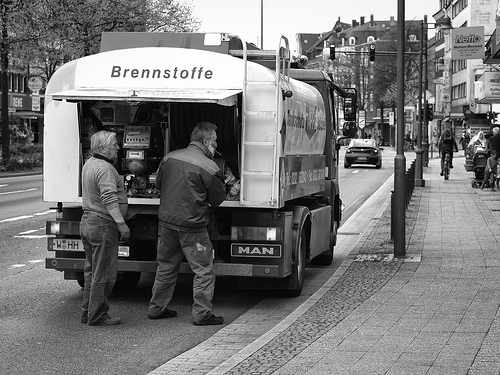What are the two individuals doing by the truck? The two individuals appear to be engaged in a task involving the fuel truck labeled 'Brennstoffe,' which translates to 'fuels' in German. It suggests that they might be either delivering or operating equipment associated with fuel distribution. 